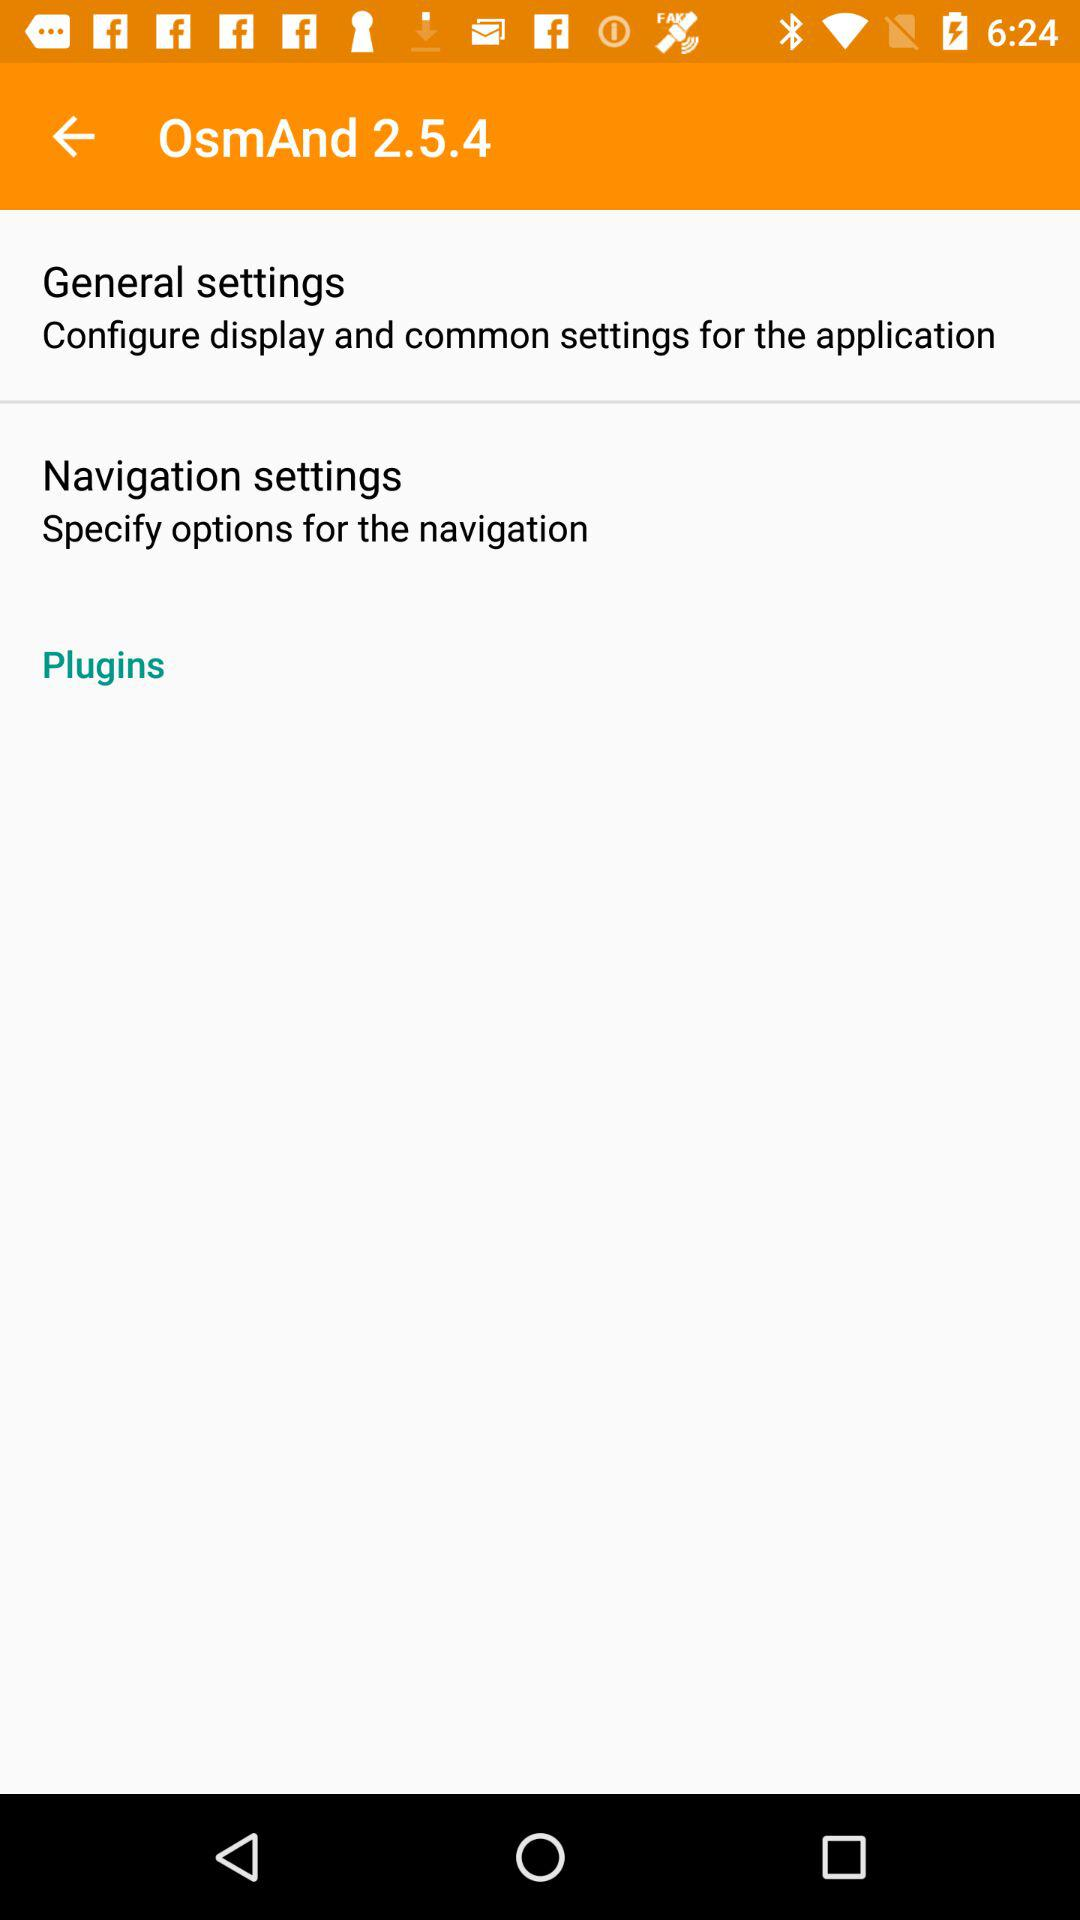What is the name of the application? The name of the application is "OsmAnd". 